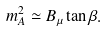Convert formula to latex. <formula><loc_0><loc_0><loc_500><loc_500>m _ { A } ^ { 2 } \simeq B _ { \mu } \tan \beta .</formula> 